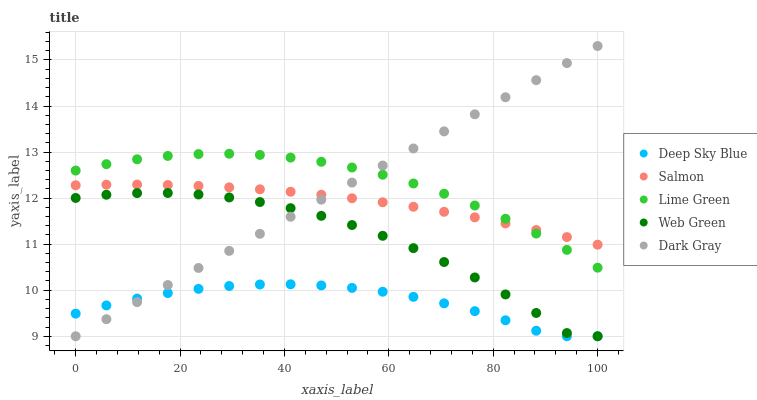Does Deep Sky Blue have the minimum area under the curve?
Answer yes or no. Yes. Does Lime Green have the maximum area under the curve?
Answer yes or no. Yes. Does Salmon have the minimum area under the curve?
Answer yes or no. No. Does Salmon have the maximum area under the curve?
Answer yes or no. No. Is Dark Gray the smoothest?
Answer yes or no. Yes. Is Web Green the roughest?
Answer yes or no. Yes. Is Lime Green the smoothest?
Answer yes or no. No. Is Lime Green the roughest?
Answer yes or no. No. Does Dark Gray have the lowest value?
Answer yes or no. Yes. Does Lime Green have the lowest value?
Answer yes or no. No. Does Dark Gray have the highest value?
Answer yes or no. Yes. Does Lime Green have the highest value?
Answer yes or no. No. Is Web Green less than Lime Green?
Answer yes or no. Yes. Is Salmon greater than Web Green?
Answer yes or no. Yes. Does Salmon intersect Dark Gray?
Answer yes or no. Yes. Is Salmon less than Dark Gray?
Answer yes or no. No. Is Salmon greater than Dark Gray?
Answer yes or no. No. Does Web Green intersect Lime Green?
Answer yes or no. No. 